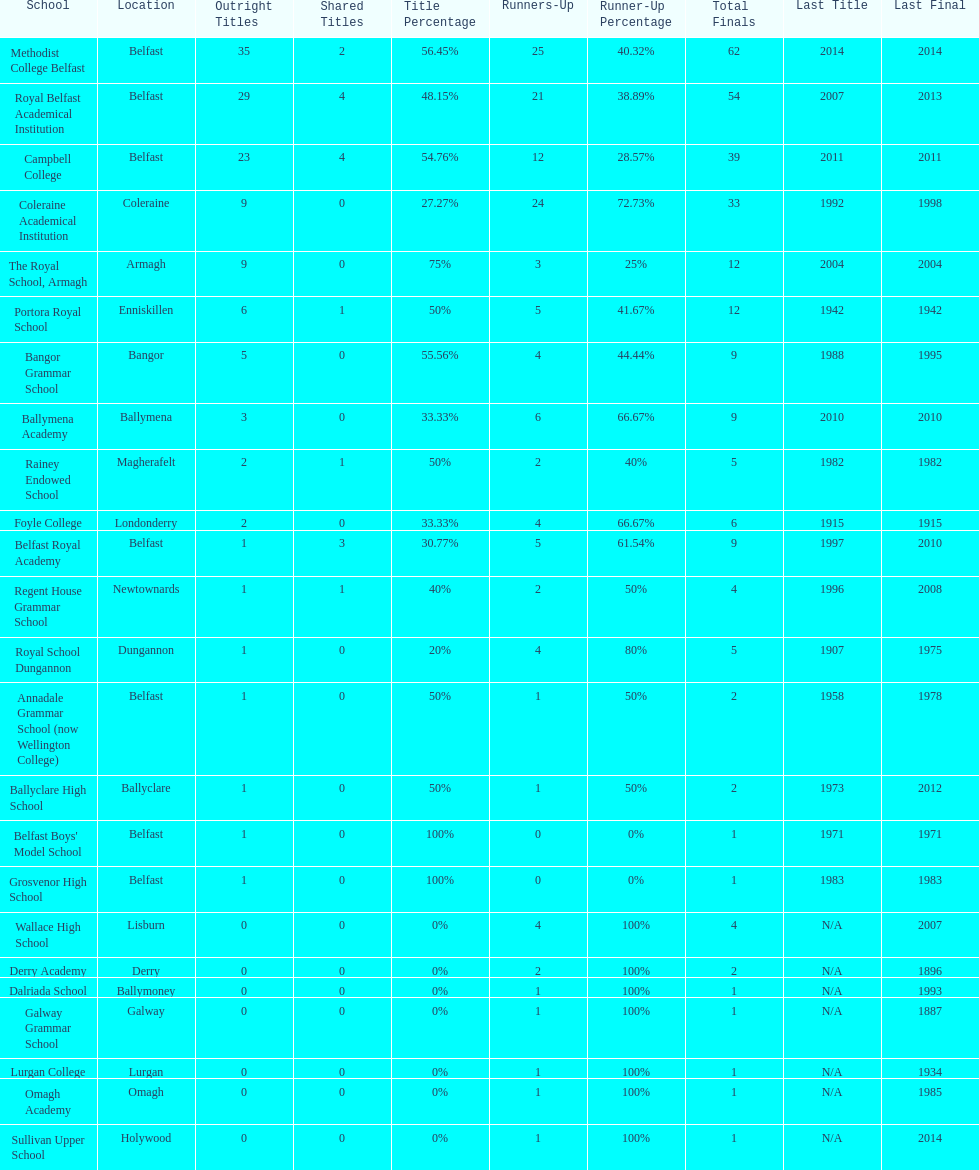What was the last year that the regent house grammar school won a title? 1996. 